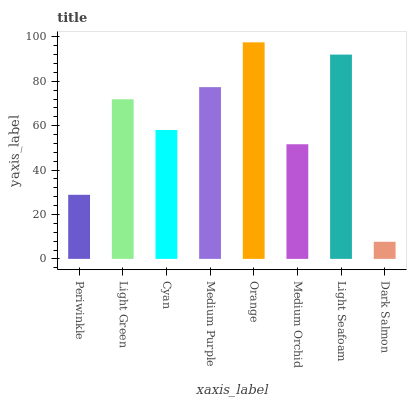Is Dark Salmon the minimum?
Answer yes or no. Yes. Is Orange the maximum?
Answer yes or no. Yes. Is Light Green the minimum?
Answer yes or no. No. Is Light Green the maximum?
Answer yes or no. No. Is Light Green greater than Periwinkle?
Answer yes or no. Yes. Is Periwinkle less than Light Green?
Answer yes or no. Yes. Is Periwinkle greater than Light Green?
Answer yes or no. No. Is Light Green less than Periwinkle?
Answer yes or no. No. Is Light Green the high median?
Answer yes or no. Yes. Is Cyan the low median?
Answer yes or no. Yes. Is Orange the high median?
Answer yes or no. No. Is Dark Salmon the low median?
Answer yes or no. No. 